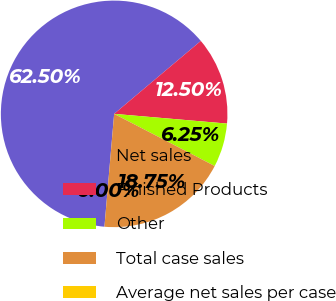Convert chart. <chart><loc_0><loc_0><loc_500><loc_500><pie_chart><fcel>Net sales<fcel>Finished Products<fcel>Other<fcel>Total case sales<fcel>Average net sales per case<nl><fcel>62.5%<fcel>12.5%<fcel>6.25%<fcel>18.75%<fcel>0.0%<nl></chart> 